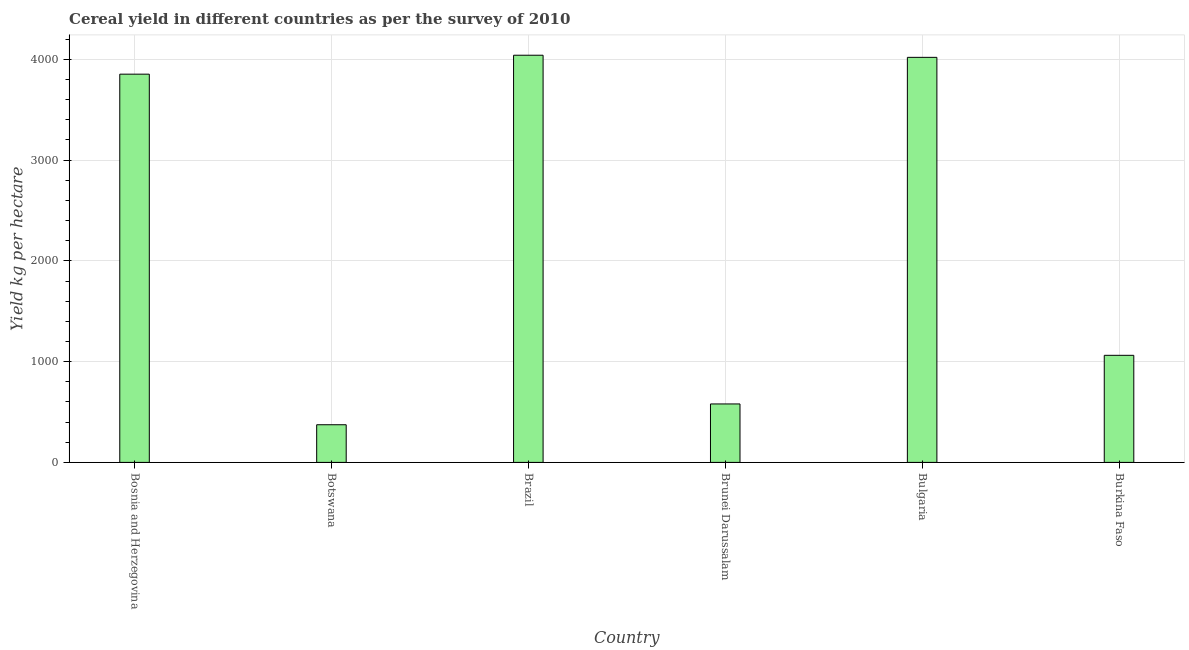Does the graph contain grids?
Keep it short and to the point. Yes. What is the title of the graph?
Ensure brevity in your answer.  Cereal yield in different countries as per the survey of 2010. What is the label or title of the Y-axis?
Provide a short and direct response. Yield kg per hectare. What is the cereal yield in Bosnia and Herzegovina?
Offer a terse response. 3852.95. Across all countries, what is the maximum cereal yield?
Provide a succinct answer. 4040.84. Across all countries, what is the minimum cereal yield?
Your response must be concise. 373.65. In which country was the cereal yield maximum?
Your response must be concise. Brazil. In which country was the cereal yield minimum?
Offer a terse response. Botswana. What is the sum of the cereal yield?
Offer a terse response. 1.39e+04. What is the difference between the cereal yield in Bosnia and Herzegovina and Brunei Darussalam?
Ensure brevity in your answer.  3272.86. What is the average cereal yield per country?
Offer a very short reply. 2321.68. What is the median cereal yield?
Provide a succinct answer. 2457.82. In how many countries, is the cereal yield greater than 200 kg per hectare?
Provide a succinct answer. 6. What is the ratio of the cereal yield in Bulgaria to that in Burkina Faso?
Your response must be concise. 3.78. What is the difference between the highest and the second highest cereal yield?
Provide a succinct answer. 20.95. What is the difference between the highest and the lowest cereal yield?
Ensure brevity in your answer.  3667.19. In how many countries, is the cereal yield greater than the average cereal yield taken over all countries?
Make the answer very short. 3. How many countries are there in the graph?
Your answer should be compact. 6. What is the Yield kg per hectare in Bosnia and Herzegovina?
Provide a succinct answer. 3852.95. What is the Yield kg per hectare of Botswana?
Make the answer very short. 373.65. What is the Yield kg per hectare in Brazil?
Your answer should be very brief. 4040.84. What is the Yield kg per hectare in Brunei Darussalam?
Your answer should be very brief. 580.09. What is the Yield kg per hectare in Bulgaria?
Keep it short and to the point. 4019.89. What is the Yield kg per hectare in Burkina Faso?
Your response must be concise. 1062.69. What is the difference between the Yield kg per hectare in Bosnia and Herzegovina and Botswana?
Your response must be concise. 3479.3. What is the difference between the Yield kg per hectare in Bosnia and Herzegovina and Brazil?
Give a very brief answer. -187.88. What is the difference between the Yield kg per hectare in Bosnia and Herzegovina and Brunei Darussalam?
Provide a short and direct response. 3272.86. What is the difference between the Yield kg per hectare in Bosnia and Herzegovina and Bulgaria?
Your answer should be compact. -166.93. What is the difference between the Yield kg per hectare in Bosnia and Herzegovina and Burkina Faso?
Your response must be concise. 2790.26. What is the difference between the Yield kg per hectare in Botswana and Brazil?
Offer a very short reply. -3667.19. What is the difference between the Yield kg per hectare in Botswana and Brunei Darussalam?
Your response must be concise. -206.44. What is the difference between the Yield kg per hectare in Botswana and Bulgaria?
Offer a terse response. -3646.24. What is the difference between the Yield kg per hectare in Botswana and Burkina Faso?
Your response must be concise. -689.05. What is the difference between the Yield kg per hectare in Brazil and Brunei Darussalam?
Your answer should be very brief. 3460.75. What is the difference between the Yield kg per hectare in Brazil and Bulgaria?
Your response must be concise. 20.95. What is the difference between the Yield kg per hectare in Brazil and Burkina Faso?
Your answer should be very brief. 2978.14. What is the difference between the Yield kg per hectare in Brunei Darussalam and Bulgaria?
Your answer should be very brief. -3439.8. What is the difference between the Yield kg per hectare in Brunei Darussalam and Burkina Faso?
Your answer should be very brief. -482.61. What is the difference between the Yield kg per hectare in Bulgaria and Burkina Faso?
Your answer should be compact. 2957.19. What is the ratio of the Yield kg per hectare in Bosnia and Herzegovina to that in Botswana?
Your response must be concise. 10.31. What is the ratio of the Yield kg per hectare in Bosnia and Herzegovina to that in Brazil?
Give a very brief answer. 0.95. What is the ratio of the Yield kg per hectare in Bosnia and Herzegovina to that in Brunei Darussalam?
Keep it short and to the point. 6.64. What is the ratio of the Yield kg per hectare in Bosnia and Herzegovina to that in Bulgaria?
Ensure brevity in your answer.  0.96. What is the ratio of the Yield kg per hectare in Bosnia and Herzegovina to that in Burkina Faso?
Your answer should be compact. 3.63. What is the ratio of the Yield kg per hectare in Botswana to that in Brazil?
Your answer should be compact. 0.09. What is the ratio of the Yield kg per hectare in Botswana to that in Brunei Darussalam?
Your answer should be very brief. 0.64. What is the ratio of the Yield kg per hectare in Botswana to that in Bulgaria?
Ensure brevity in your answer.  0.09. What is the ratio of the Yield kg per hectare in Botswana to that in Burkina Faso?
Your response must be concise. 0.35. What is the ratio of the Yield kg per hectare in Brazil to that in Brunei Darussalam?
Give a very brief answer. 6.97. What is the ratio of the Yield kg per hectare in Brazil to that in Burkina Faso?
Offer a terse response. 3.8. What is the ratio of the Yield kg per hectare in Brunei Darussalam to that in Bulgaria?
Offer a very short reply. 0.14. What is the ratio of the Yield kg per hectare in Brunei Darussalam to that in Burkina Faso?
Your response must be concise. 0.55. What is the ratio of the Yield kg per hectare in Bulgaria to that in Burkina Faso?
Provide a short and direct response. 3.78. 